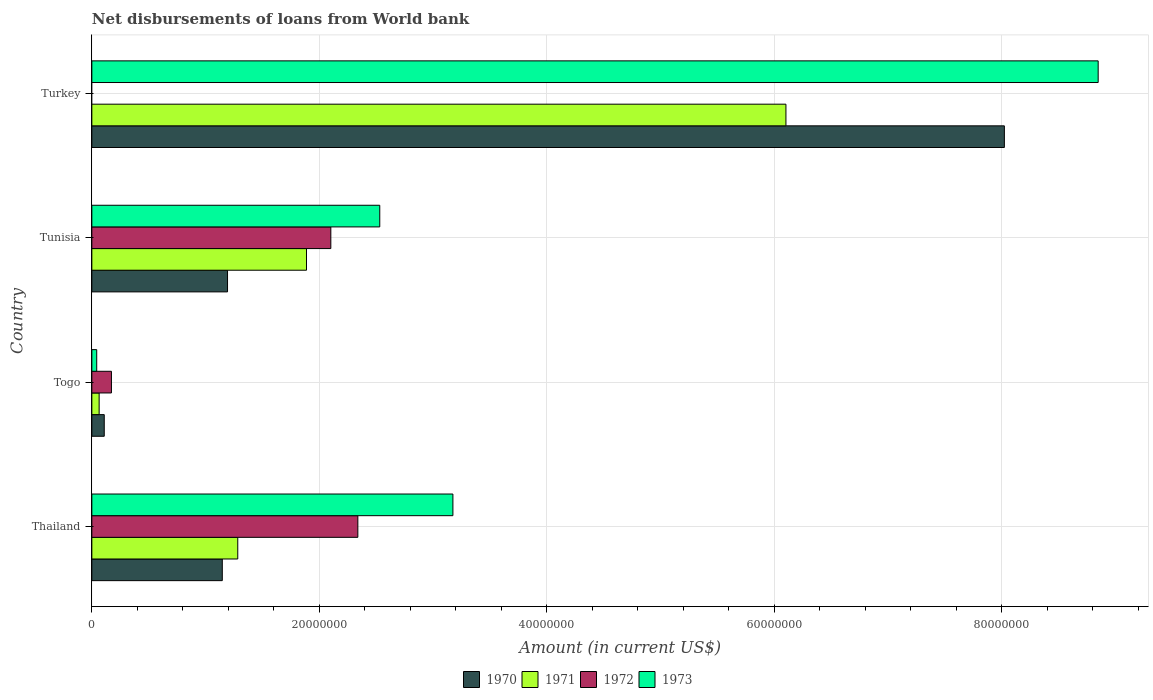How many different coloured bars are there?
Your answer should be compact. 4. How many bars are there on the 2nd tick from the bottom?
Make the answer very short. 4. In how many cases, is the number of bars for a given country not equal to the number of legend labels?
Keep it short and to the point. 1. What is the amount of loan disbursed from World Bank in 1973 in Togo?
Keep it short and to the point. 4.29e+05. Across all countries, what is the maximum amount of loan disbursed from World Bank in 1971?
Your response must be concise. 6.10e+07. In which country was the amount of loan disbursed from World Bank in 1973 maximum?
Your response must be concise. Turkey. What is the total amount of loan disbursed from World Bank in 1971 in the graph?
Your answer should be very brief. 9.34e+07. What is the difference between the amount of loan disbursed from World Bank in 1971 in Togo and that in Turkey?
Offer a very short reply. -6.04e+07. What is the difference between the amount of loan disbursed from World Bank in 1972 in Togo and the amount of loan disbursed from World Bank in 1973 in Turkey?
Offer a terse response. -8.68e+07. What is the average amount of loan disbursed from World Bank in 1972 per country?
Ensure brevity in your answer.  1.15e+07. What is the difference between the amount of loan disbursed from World Bank in 1971 and amount of loan disbursed from World Bank in 1972 in Tunisia?
Ensure brevity in your answer.  -2.14e+06. What is the ratio of the amount of loan disbursed from World Bank in 1970 in Togo to that in Turkey?
Your answer should be very brief. 0.01. Is the difference between the amount of loan disbursed from World Bank in 1971 in Togo and Tunisia greater than the difference between the amount of loan disbursed from World Bank in 1972 in Togo and Tunisia?
Give a very brief answer. Yes. What is the difference between the highest and the second highest amount of loan disbursed from World Bank in 1971?
Your answer should be compact. 4.22e+07. What is the difference between the highest and the lowest amount of loan disbursed from World Bank in 1970?
Keep it short and to the point. 7.91e+07. In how many countries, is the amount of loan disbursed from World Bank in 1973 greater than the average amount of loan disbursed from World Bank in 1973 taken over all countries?
Ensure brevity in your answer.  1. Is it the case that in every country, the sum of the amount of loan disbursed from World Bank in 1973 and amount of loan disbursed from World Bank in 1972 is greater than the sum of amount of loan disbursed from World Bank in 1971 and amount of loan disbursed from World Bank in 1970?
Provide a short and direct response. No. Is it the case that in every country, the sum of the amount of loan disbursed from World Bank in 1971 and amount of loan disbursed from World Bank in 1973 is greater than the amount of loan disbursed from World Bank in 1970?
Make the answer very short. No. Are all the bars in the graph horizontal?
Offer a very short reply. Yes. What is the difference between two consecutive major ticks on the X-axis?
Provide a short and direct response. 2.00e+07. Are the values on the major ticks of X-axis written in scientific E-notation?
Ensure brevity in your answer.  No. Does the graph contain any zero values?
Your answer should be very brief. Yes. Does the graph contain grids?
Provide a short and direct response. Yes. Where does the legend appear in the graph?
Provide a short and direct response. Bottom center. How many legend labels are there?
Ensure brevity in your answer.  4. How are the legend labels stacked?
Keep it short and to the point. Horizontal. What is the title of the graph?
Ensure brevity in your answer.  Net disbursements of loans from World bank. Does "2014" appear as one of the legend labels in the graph?
Offer a very short reply. No. What is the label or title of the Y-axis?
Make the answer very short. Country. What is the Amount (in current US$) of 1970 in Thailand?
Keep it short and to the point. 1.15e+07. What is the Amount (in current US$) in 1971 in Thailand?
Your answer should be very brief. 1.28e+07. What is the Amount (in current US$) of 1972 in Thailand?
Your response must be concise. 2.34e+07. What is the Amount (in current US$) in 1973 in Thailand?
Keep it short and to the point. 3.17e+07. What is the Amount (in current US$) of 1970 in Togo?
Make the answer very short. 1.09e+06. What is the Amount (in current US$) of 1971 in Togo?
Keep it short and to the point. 6.42e+05. What is the Amount (in current US$) of 1972 in Togo?
Provide a succinct answer. 1.72e+06. What is the Amount (in current US$) in 1973 in Togo?
Provide a short and direct response. 4.29e+05. What is the Amount (in current US$) of 1970 in Tunisia?
Your answer should be very brief. 1.19e+07. What is the Amount (in current US$) of 1971 in Tunisia?
Your answer should be compact. 1.89e+07. What is the Amount (in current US$) of 1972 in Tunisia?
Offer a terse response. 2.10e+07. What is the Amount (in current US$) in 1973 in Tunisia?
Provide a succinct answer. 2.53e+07. What is the Amount (in current US$) of 1970 in Turkey?
Give a very brief answer. 8.02e+07. What is the Amount (in current US$) of 1971 in Turkey?
Offer a very short reply. 6.10e+07. What is the Amount (in current US$) in 1972 in Turkey?
Provide a short and direct response. 0. What is the Amount (in current US$) in 1973 in Turkey?
Offer a terse response. 8.85e+07. Across all countries, what is the maximum Amount (in current US$) in 1970?
Offer a very short reply. 8.02e+07. Across all countries, what is the maximum Amount (in current US$) in 1971?
Your answer should be compact. 6.10e+07. Across all countries, what is the maximum Amount (in current US$) in 1972?
Offer a very short reply. 2.34e+07. Across all countries, what is the maximum Amount (in current US$) of 1973?
Offer a very short reply. 8.85e+07. Across all countries, what is the minimum Amount (in current US$) in 1970?
Your answer should be very brief. 1.09e+06. Across all countries, what is the minimum Amount (in current US$) in 1971?
Your answer should be very brief. 6.42e+05. Across all countries, what is the minimum Amount (in current US$) in 1972?
Offer a terse response. 0. Across all countries, what is the minimum Amount (in current US$) of 1973?
Keep it short and to the point. 4.29e+05. What is the total Amount (in current US$) in 1970 in the graph?
Your answer should be compact. 1.05e+08. What is the total Amount (in current US$) of 1971 in the graph?
Your answer should be compact. 9.34e+07. What is the total Amount (in current US$) in 1972 in the graph?
Keep it short and to the point. 4.61e+07. What is the total Amount (in current US$) in 1973 in the graph?
Provide a short and direct response. 1.46e+08. What is the difference between the Amount (in current US$) of 1970 in Thailand and that in Togo?
Your response must be concise. 1.04e+07. What is the difference between the Amount (in current US$) of 1971 in Thailand and that in Togo?
Provide a short and direct response. 1.22e+07. What is the difference between the Amount (in current US$) in 1972 in Thailand and that in Togo?
Your response must be concise. 2.17e+07. What is the difference between the Amount (in current US$) of 1973 in Thailand and that in Togo?
Offer a terse response. 3.13e+07. What is the difference between the Amount (in current US$) of 1970 in Thailand and that in Tunisia?
Provide a short and direct response. -4.60e+05. What is the difference between the Amount (in current US$) of 1971 in Thailand and that in Tunisia?
Your answer should be compact. -6.04e+06. What is the difference between the Amount (in current US$) of 1972 in Thailand and that in Tunisia?
Keep it short and to the point. 2.38e+06. What is the difference between the Amount (in current US$) of 1973 in Thailand and that in Tunisia?
Give a very brief answer. 6.43e+06. What is the difference between the Amount (in current US$) of 1970 in Thailand and that in Turkey?
Your answer should be very brief. -6.88e+07. What is the difference between the Amount (in current US$) in 1971 in Thailand and that in Turkey?
Make the answer very short. -4.82e+07. What is the difference between the Amount (in current US$) of 1973 in Thailand and that in Turkey?
Your answer should be compact. -5.67e+07. What is the difference between the Amount (in current US$) in 1970 in Togo and that in Tunisia?
Your response must be concise. -1.08e+07. What is the difference between the Amount (in current US$) in 1971 in Togo and that in Tunisia?
Make the answer very short. -1.82e+07. What is the difference between the Amount (in current US$) of 1972 in Togo and that in Tunisia?
Ensure brevity in your answer.  -1.93e+07. What is the difference between the Amount (in current US$) in 1973 in Togo and that in Tunisia?
Provide a succinct answer. -2.49e+07. What is the difference between the Amount (in current US$) in 1970 in Togo and that in Turkey?
Give a very brief answer. -7.91e+07. What is the difference between the Amount (in current US$) of 1971 in Togo and that in Turkey?
Make the answer very short. -6.04e+07. What is the difference between the Amount (in current US$) of 1973 in Togo and that in Turkey?
Give a very brief answer. -8.80e+07. What is the difference between the Amount (in current US$) of 1970 in Tunisia and that in Turkey?
Offer a very short reply. -6.83e+07. What is the difference between the Amount (in current US$) of 1971 in Tunisia and that in Turkey?
Offer a terse response. -4.22e+07. What is the difference between the Amount (in current US$) of 1973 in Tunisia and that in Turkey?
Keep it short and to the point. -6.32e+07. What is the difference between the Amount (in current US$) in 1970 in Thailand and the Amount (in current US$) in 1971 in Togo?
Your answer should be compact. 1.08e+07. What is the difference between the Amount (in current US$) of 1970 in Thailand and the Amount (in current US$) of 1972 in Togo?
Your response must be concise. 9.75e+06. What is the difference between the Amount (in current US$) of 1970 in Thailand and the Amount (in current US$) of 1973 in Togo?
Provide a short and direct response. 1.10e+07. What is the difference between the Amount (in current US$) in 1971 in Thailand and the Amount (in current US$) in 1972 in Togo?
Your response must be concise. 1.11e+07. What is the difference between the Amount (in current US$) of 1971 in Thailand and the Amount (in current US$) of 1973 in Togo?
Offer a terse response. 1.24e+07. What is the difference between the Amount (in current US$) of 1972 in Thailand and the Amount (in current US$) of 1973 in Togo?
Your answer should be very brief. 2.30e+07. What is the difference between the Amount (in current US$) of 1970 in Thailand and the Amount (in current US$) of 1971 in Tunisia?
Ensure brevity in your answer.  -7.40e+06. What is the difference between the Amount (in current US$) of 1970 in Thailand and the Amount (in current US$) of 1972 in Tunisia?
Give a very brief answer. -9.54e+06. What is the difference between the Amount (in current US$) in 1970 in Thailand and the Amount (in current US$) in 1973 in Tunisia?
Ensure brevity in your answer.  -1.38e+07. What is the difference between the Amount (in current US$) in 1971 in Thailand and the Amount (in current US$) in 1972 in Tunisia?
Your response must be concise. -8.18e+06. What is the difference between the Amount (in current US$) of 1971 in Thailand and the Amount (in current US$) of 1973 in Tunisia?
Ensure brevity in your answer.  -1.25e+07. What is the difference between the Amount (in current US$) of 1972 in Thailand and the Amount (in current US$) of 1973 in Tunisia?
Keep it short and to the point. -1.93e+06. What is the difference between the Amount (in current US$) of 1970 in Thailand and the Amount (in current US$) of 1971 in Turkey?
Offer a terse response. -4.96e+07. What is the difference between the Amount (in current US$) in 1970 in Thailand and the Amount (in current US$) in 1973 in Turkey?
Provide a succinct answer. -7.70e+07. What is the difference between the Amount (in current US$) of 1971 in Thailand and the Amount (in current US$) of 1973 in Turkey?
Your response must be concise. -7.56e+07. What is the difference between the Amount (in current US$) of 1972 in Thailand and the Amount (in current US$) of 1973 in Turkey?
Give a very brief answer. -6.51e+07. What is the difference between the Amount (in current US$) in 1970 in Togo and the Amount (in current US$) in 1971 in Tunisia?
Provide a short and direct response. -1.78e+07. What is the difference between the Amount (in current US$) in 1970 in Togo and the Amount (in current US$) in 1972 in Tunisia?
Provide a short and direct response. -1.99e+07. What is the difference between the Amount (in current US$) in 1970 in Togo and the Amount (in current US$) in 1973 in Tunisia?
Your answer should be very brief. -2.42e+07. What is the difference between the Amount (in current US$) of 1971 in Togo and the Amount (in current US$) of 1972 in Tunisia?
Give a very brief answer. -2.04e+07. What is the difference between the Amount (in current US$) in 1971 in Togo and the Amount (in current US$) in 1973 in Tunisia?
Provide a succinct answer. -2.47e+07. What is the difference between the Amount (in current US$) in 1972 in Togo and the Amount (in current US$) in 1973 in Tunisia?
Offer a very short reply. -2.36e+07. What is the difference between the Amount (in current US$) of 1970 in Togo and the Amount (in current US$) of 1971 in Turkey?
Keep it short and to the point. -5.99e+07. What is the difference between the Amount (in current US$) of 1970 in Togo and the Amount (in current US$) of 1973 in Turkey?
Your response must be concise. -8.74e+07. What is the difference between the Amount (in current US$) of 1971 in Togo and the Amount (in current US$) of 1973 in Turkey?
Your answer should be very brief. -8.78e+07. What is the difference between the Amount (in current US$) in 1972 in Togo and the Amount (in current US$) in 1973 in Turkey?
Provide a short and direct response. -8.68e+07. What is the difference between the Amount (in current US$) of 1970 in Tunisia and the Amount (in current US$) of 1971 in Turkey?
Make the answer very short. -4.91e+07. What is the difference between the Amount (in current US$) of 1970 in Tunisia and the Amount (in current US$) of 1973 in Turkey?
Your response must be concise. -7.65e+07. What is the difference between the Amount (in current US$) of 1971 in Tunisia and the Amount (in current US$) of 1973 in Turkey?
Offer a very short reply. -6.96e+07. What is the difference between the Amount (in current US$) in 1972 in Tunisia and the Amount (in current US$) in 1973 in Turkey?
Offer a very short reply. -6.75e+07. What is the average Amount (in current US$) in 1970 per country?
Your answer should be very brief. 2.62e+07. What is the average Amount (in current US$) of 1971 per country?
Provide a short and direct response. 2.33e+07. What is the average Amount (in current US$) of 1972 per country?
Give a very brief answer. 1.15e+07. What is the average Amount (in current US$) in 1973 per country?
Make the answer very short. 3.65e+07. What is the difference between the Amount (in current US$) in 1970 and Amount (in current US$) in 1971 in Thailand?
Make the answer very short. -1.36e+06. What is the difference between the Amount (in current US$) in 1970 and Amount (in current US$) in 1972 in Thailand?
Make the answer very short. -1.19e+07. What is the difference between the Amount (in current US$) of 1970 and Amount (in current US$) of 1973 in Thailand?
Keep it short and to the point. -2.03e+07. What is the difference between the Amount (in current US$) in 1971 and Amount (in current US$) in 1972 in Thailand?
Offer a terse response. -1.06e+07. What is the difference between the Amount (in current US$) in 1971 and Amount (in current US$) in 1973 in Thailand?
Your answer should be very brief. -1.89e+07. What is the difference between the Amount (in current US$) of 1972 and Amount (in current US$) of 1973 in Thailand?
Your response must be concise. -8.36e+06. What is the difference between the Amount (in current US$) in 1970 and Amount (in current US$) in 1971 in Togo?
Your response must be concise. 4.49e+05. What is the difference between the Amount (in current US$) of 1970 and Amount (in current US$) of 1972 in Togo?
Your answer should be compact. -6.31e+05. What is the difference between the Amount (in current US$) in 1970 and Amount (in current US$) in 1973 in Togo?
Offer a terse response. 6.62e+05. What is the difference between the Amount (in current US$) in 1971 and Amount (in current US$) in 1972 in Togo?
Your answer should be very brief. -1.08e+06. What is the difference between the Amount (in current US$) in 1971 and Amount (in current US$) in 1973 in Togo?
Provide a short and direct response. 2.13e+05. What is the difference between the Amount (in current US$) in 1972 and Amount (in current US$) in 1973 in Togo?
Your response must be concise. 1.29e+06. What is the difference between the Amount (in current US$) of 1970 and Amount (in current US$) of 1971 in Tunisia?
Offer a terse response. -6.94e+06. What is the difference between the Amount (in current US$) of 1970 and Amount (in current US$) of 1972 in Tunisia?
Offer a very short reply. -9.08e+06. What is the difference between the Amount (in current US$) of 1970 and Amount (in current US$) of 1973 in Tunisia?
Offer a terse response. -1.34e+07. What is the difference between the Amount (in current US$) of 1971 and Amount (in current US$) of 1972 in Tunisia?
Offer a terse response. -2.14e+06. What is the difference between the Amount (in current US$) of 1971 and Amount (in current US$) of 1973 in Tunisia?
Ensure brevity in your answer.  -6.44e+06. What is the difference between the Amount (in current US$) in 1972 and Amount (in current US$) in 1973 in Tunisia?
Provide a succinct answer. -4.30e+06. What is the difference between the Amount (in current US$) in 1970 and Amount (in current US$) in 1971 in Turkey?
Your answer should be very brief. 1.92e+07. What is the difference between the Amount (in current US$) in 1970 and Amount (in current US$) in 1973 in Turkey?
Your answer should be compact. -8.25e+06. What is the difference between the Amount (in current US$) of 1971 and Amount (in current US$) of 1973 in Turkey?
Provide a short and direct response. -2.75e+07. What is the ratio of the Amount (in current US$) of 1970 in Thailand to that in Togo?
Provide a succinct answer. 10.51. What is the ratio of the Amount (in current US$) in 1971 in Thailand to that in Togo?
Give a very brief answer. 19.98. What is the ratio of the Amount (in current US$) of 1972 in Thailand to that in Togo?
Make the answer very short. 13.58. What is the ratio of the Amount (in current US$) in 1973 in Thailand to that in Togo?
Make the answer very short. 74. What is the ratio of the Amount (in current US$) of 1970 in Thailand to that in Tunisia?
Offer a very short reply. 0.96. What is the ratio of the Amount (in current US$) of 1971 in Thailand to that in Tunisia?
Give a very brief answer. 0.68. What is the ratio of the Amount (in current US$) of 1972 in Thailand to that in Tunisia?
Provide a short and direct response. 1.11. What is the ratio of the Amount (in current US$) of 1973 in Thailand to that in Tunisia?
Make the answer very short. 1.25. What is the ratio of the Amount (in current US$) of 1970 in Thailand to that in Turkey?
Keep it short and to the point. 0.14. What is the ratio of the Amount (in current US$) of 1971 in Thailand to that in Turkey?
Provide a short and direct response. 0.21. What is the ratio of the Amount (in current US$) of 1973 in Thailand to that in Turkey?
Offer a very short reply. 0.36. What is the ratio of the Amount (in current US$) in 1970 in Togo to that in Tunisia?
Offer a terse response. 0.09. What is the ratio of the Amount (in current US$) in 1971 in Togo to that in Tunisia?
Your answer should be very brief. 0.03. What is the ratio of the Amount (in current US$) of 1972 in Togo to that in Tunisia?
Provide a succinct answer. 0.08. What is the ratio of the Amount (in current US$) in 1973 in Togo to that in Tunisia?
Provide a succinct answer. 0.02. What is the ratio of the Amount (in current US$) in 1970 in Togo to that in Turkey?
Make the answer very short. 0.01. What is the ratio of the Amount (in current US$) in 1971 in Togo to that in Turkey?
Offer a terse response. 0.01. What is the ratio of the Amount (in current US$) of 1973 in Togo to that in Turkey?
Your answer should be compact. 0. What is the ratio of the Amount (in current US$) in 1970 in Tunisia to that in Turkey?
Your answer should be very brief. 0.15. What is the ratio of the Amount (in current US$) of 1971 in Tunisia to that in Turkey?
Your response must be concise. 0.31. What is the ratio of the Amount (in current US$) in 1973 in Tunisia to that in Turkey?
Your response must be concise. 0.29. What is the difference between the highest and the second highest Amount (in current US$) in 1970?
Make the answer very short. 6.83e+07. What is the difference between the highest and the second highest Amount (in current US$) of 1971?
Make the answer very short. 4.22e+07. What is the difference between the highest and the second highest Amount (in current US$) in 1972?
Offer a very short reply. 2.38e+06. What is the difference between the highest and the second highest Amount (in current US$) in 1973?
Provide a short and direct response. 5.67e+07. What is the difference between the highest and the lowest Amount (in current US$) of 1970?
Provide a short and direct response. 7.91e+07. What is the difference between the highest and the lowest Amount (in current US$) of 1971?
Provide a succinct answer. 6.04e+07. What is the difference between the highest and the lowest Amount (in current US$) of 1972?
Ensure brevity in your answer.  2.34e+07. What is the difference between the highest and the lowest Amount (in current US$) in 1973?
Your response must be concise. 8.80e+07. 